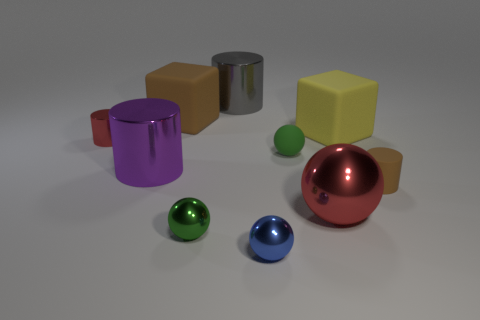The yellow block that is the same material as the tiny brown cylinder is what size?
Make the answer very short. Large. What material is the big brown cube?
Keep it short and to the point. Rubber. There is a shiny object that is the same color as the large sphere; what size is it?
Your response must be concise. Small. There is a blue metallic thing; is it the same shape as the green metal thing left of the rubber sphere?
Offer a very short reply. Yes. What material is the thing behind the large brown block that is behind the large cylinder that is left of the large brown block?
Offer a very short reply. Metal. What number of cyan matte things are there?
Provide a succinct answer. 0. What number of cyan objects are cylinders or metal cubes?
Your answer should be compact. 0. What number of other objects are there of the same shape as the large gray object?
Make the answer very short. 3. Is the color of the large metallic thing in front of the tiny brown cylinder the same as the small cylinder on the left side of the tiny blue metallic thing?
Provide a succinct answer. Yes. What number of tiny things are brown cylinders or green metallic objects?
Keep it short and to the point. 2. 